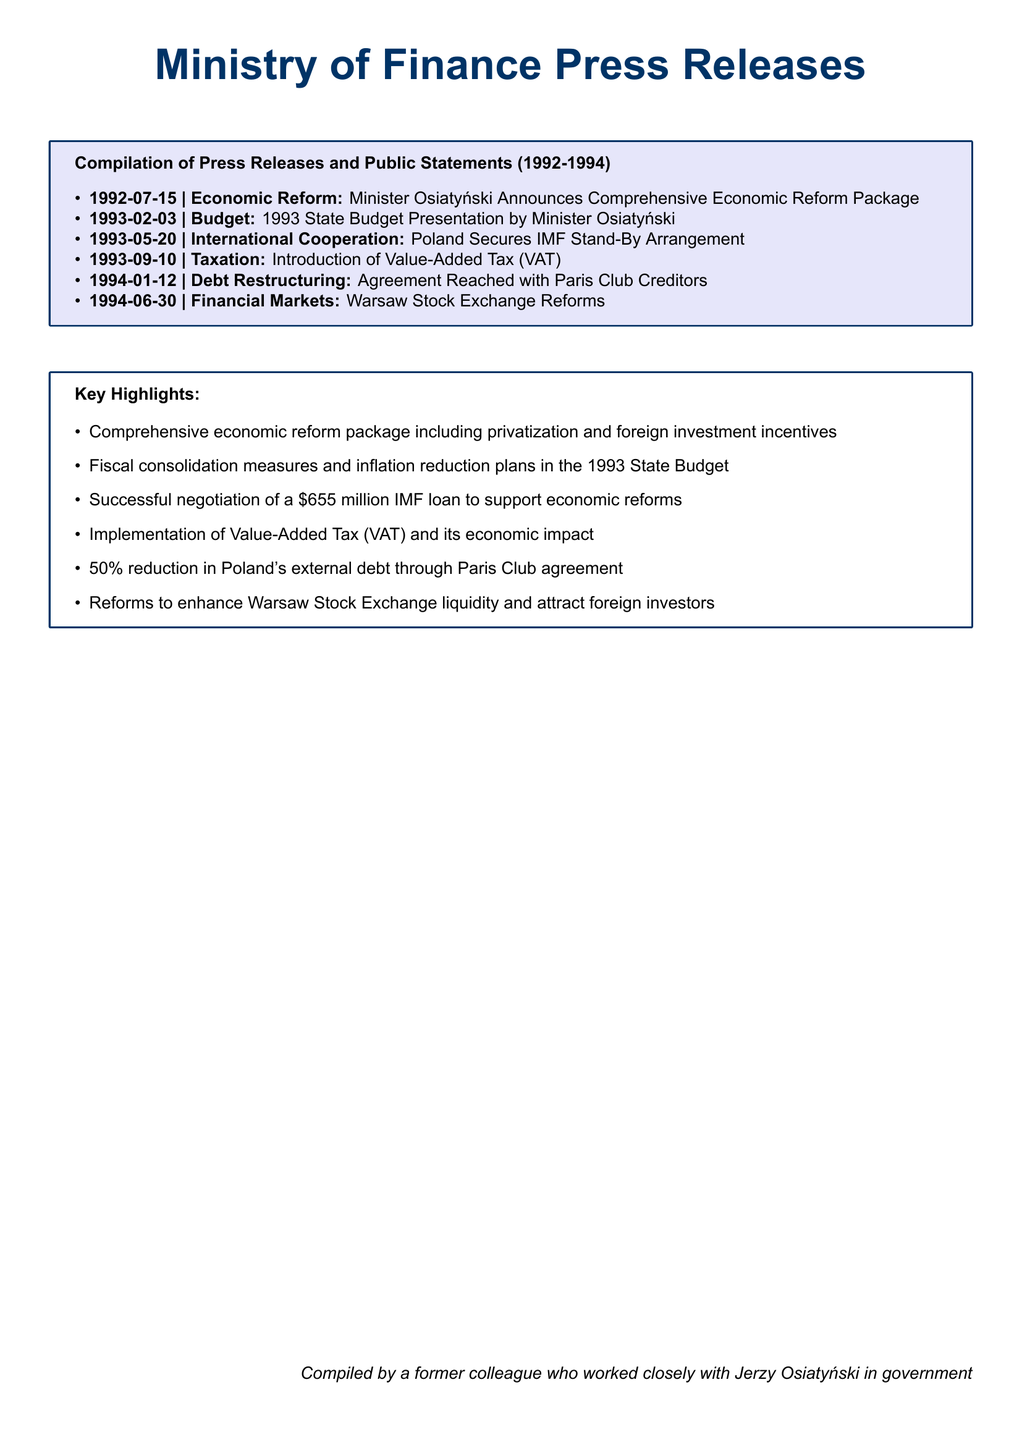What is the date of the comprehensive economic reform announcement? The date of the announcement is listed in the document under Economic Reform, which is 1992-07-15.
Answer: 1992-07-15 Who presented the 1993 State Budget? The document states that Minister Osiatyński presented the 1993 State Budget.
Answer: Minister Osiatyński How much was the IMF loan secured by Poland in May 1993? The document mentions that Poland secured a $655 million IMF loan.
Answer: $655 million What is the title of the press release on taxation? The document specifies the introduction of Value-Added Tax (VAT) as the title for the taxation press release.
Answer: Introduction of Value-Added Tax (VAT) Which year did the agreement with Paris Club Creditors take place? The document states the agreement was reached on 1994-01-12, indicating the year 1994.
Answer: 1994 What key reform was mentioned for the Warsaw Stock Exchange? The document highlights reforms aimed at enhancing liquidity and attracting foreign investors.
Answer: Reforms to enhance Warsaw Stock Exchange liquidity and attract foreign investors How many press releases are listed in the compilation? The document lists six press releases under the compilation section.
Answer: Six What major topic was addressed in the key highlights section? The key highlights section addresses comprehensive economic reform details.
Answer: Comprehensive economic reform 